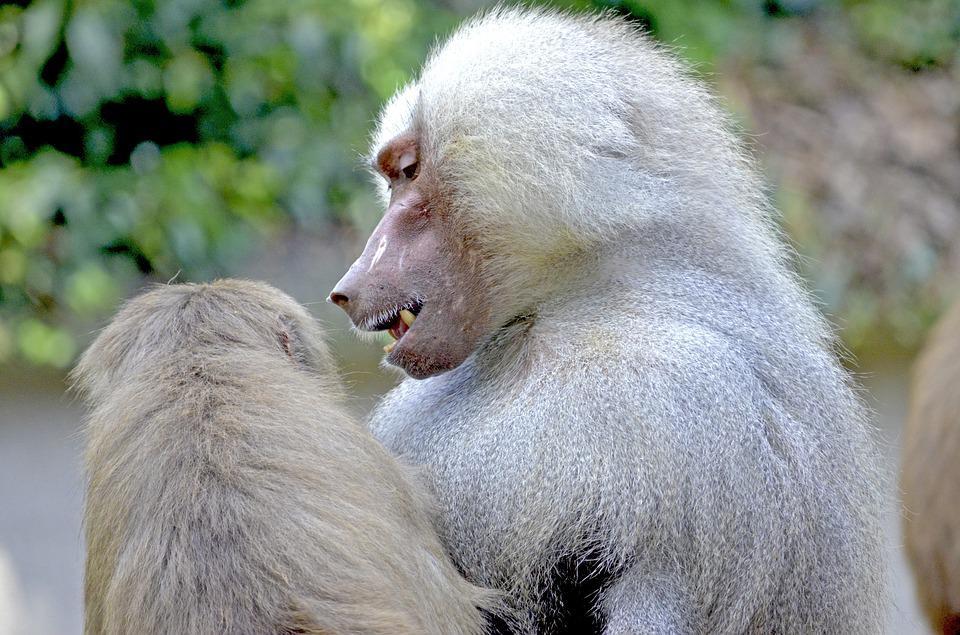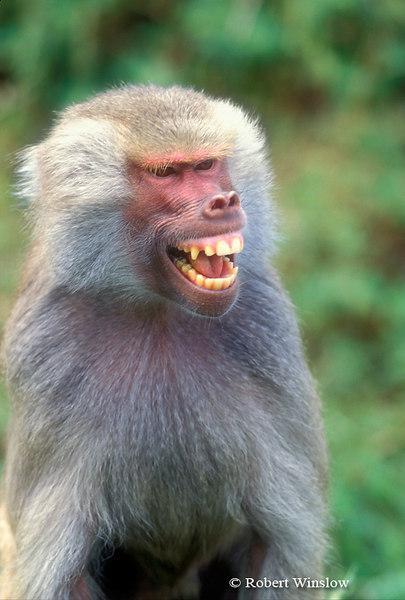The first image is the image on the left, the second image is the image on the right. Assess this claim about the two images: "The left image is of a single animal with its mouth open.". Correct or not? Answer yes or no. No. 